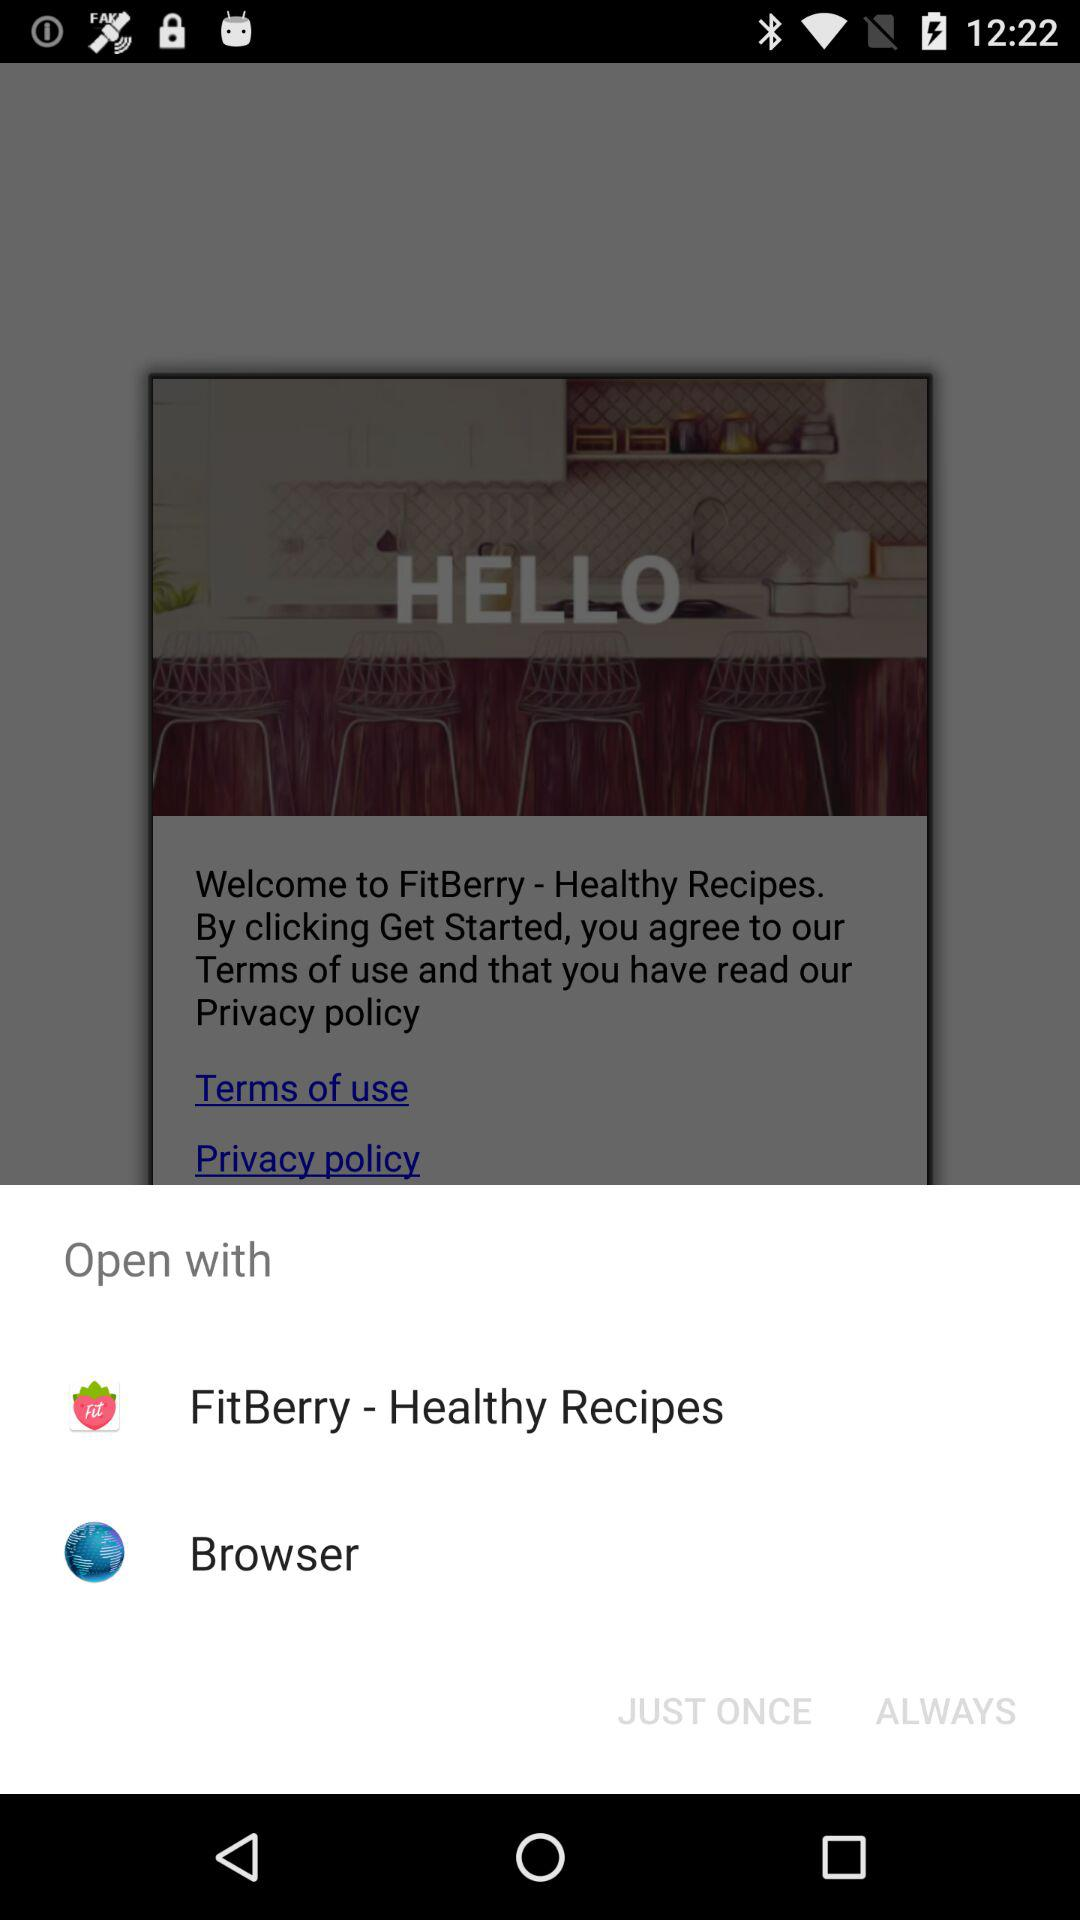Through which applications can we open? You can open through the "FitBerry - Healthy Recipes" and "Browser" applications. 